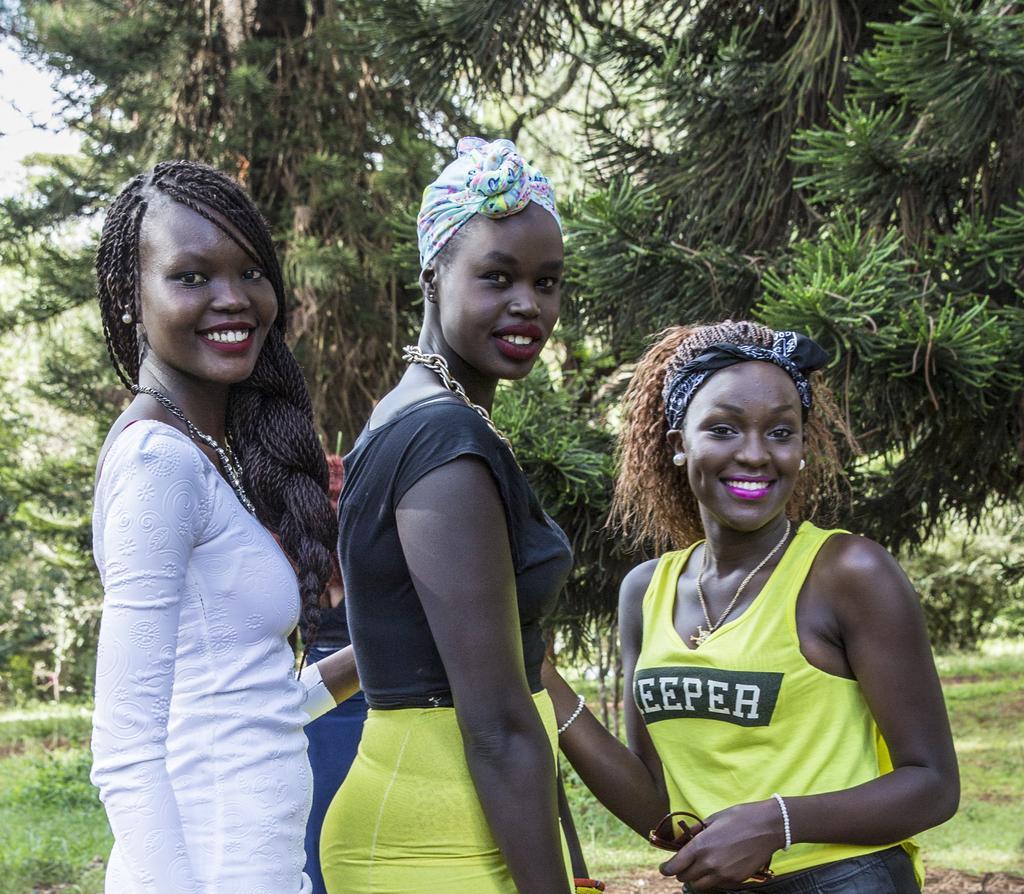Could you give a brief overview of what you see in this image? In this picture I can see three people with a smile in the foreground. I can see trees in the background. I can see green grass. 